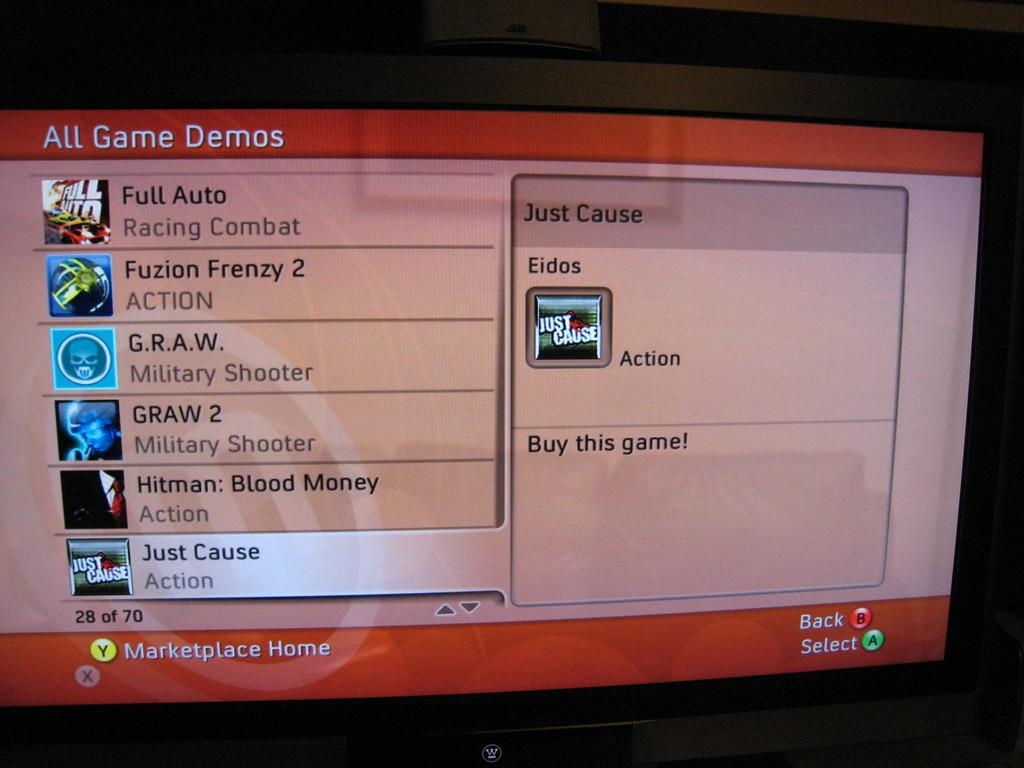What is the main object in the center of the image? There is a screen in the center of the image. What is shown on the screen? The screen displays apps, and the text "All Game Demos" is written on it. What type of beef is being cooked in the kettle in the image? There is no kettle or beef present in the image; it only features a screen displaying apps and the text "All Game Demos." 